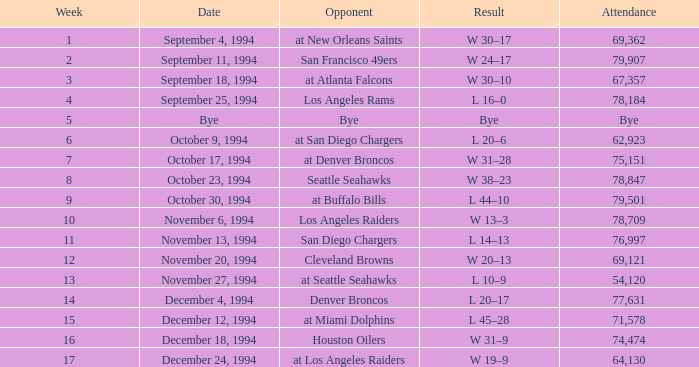What was the score of the Chiefs pre-Week 16 game that 69,362 people attended? W 30–17. 